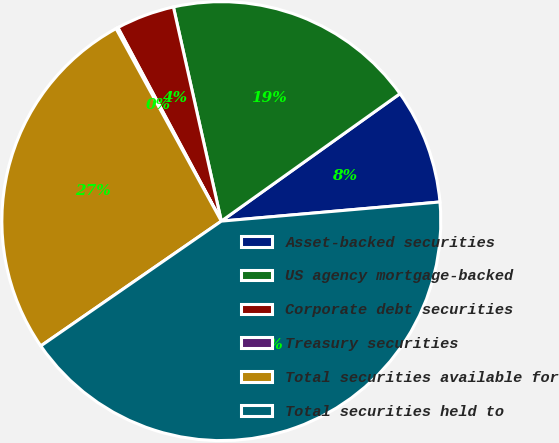Convert chart. <chart><loc_0><loc_0><loc_500><loc_500><pie_chart><fcel>Asset-backed securities<fcel>US agency mortgage-backed<fcel>Corporate debt securities<fcel>Treasury securities<fcel>Total securities available for<fcel>Total securities held to<nl><fcel>8.47%<fcel>18.64%<fcel>4.31%<fcel>0.15%<fcel>26.66%<fcel>41.76%<nl></chart> 